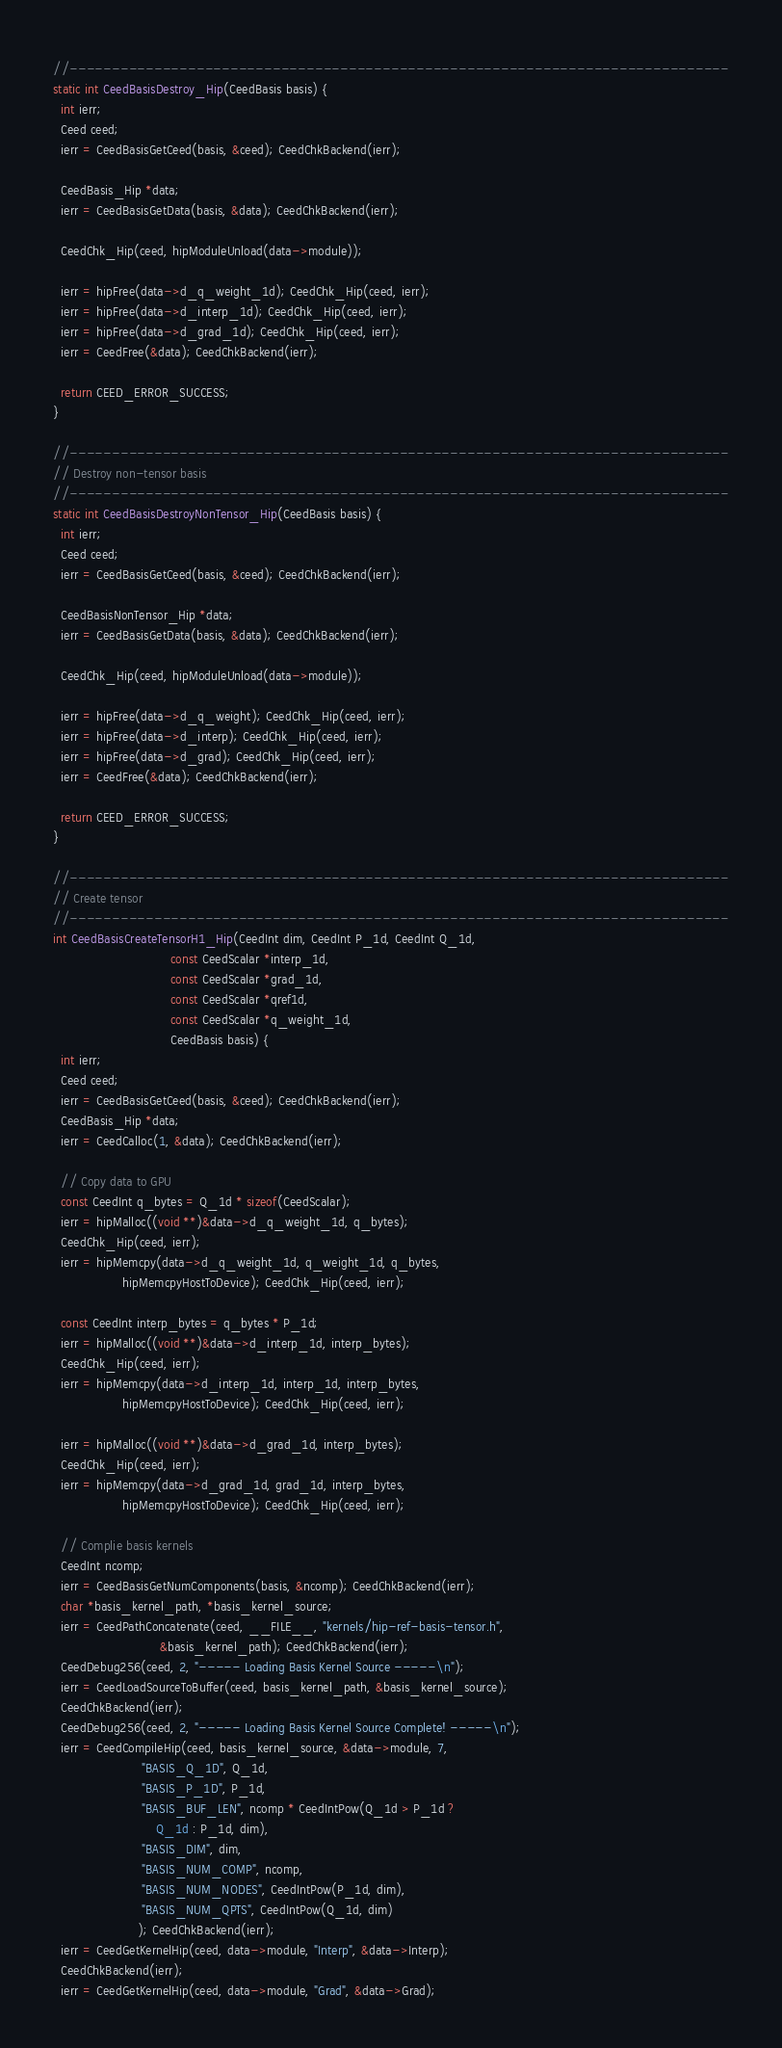<code> <loc_0><loc_0><loc_500><loc_500><_C_>//------------------------------------------------------------------------------
static int CeedBasisDestroy_Hip(CeedBasis basis) {
  int ierr;
  Ceed ceed;
  ierr = CeedBasisGetCeed(basis, &ceed); CeedChkBackend(ierr);

  CeedBasis_Hip *data;
  ierr = CeedBasisGetData(basis, &data); CeedChkBackend(ierr);

  CeedChk_Hip(ceed, hipModuleUnload(data->module));

  ierr = hipFree(data->d_q_weight_1d); CeedChk_Hip(ceed, ierr);
  ierr = hipFree(data->d_interp_1d); CeedChk_Hip(ceed, ierr);
  ierr = hipFree(data->d_grad_1d); CeedChk_Hip(ceed, ierr);
  ierr = CeedFree(&data); CeedChkBackend(ierr);

  return CEED_ERROR_SUCCESS;
}

//------------------------------------------------------------------------------
// Destroy non-tensor basis
//------------------------------------------------------------------------------
static int CeedBasisDestroyNonTensor_Hip(CeedBasis basis) {
  int ierr;
  Ceed ceed;
  ierr = CeedBasisGetCeed(basis, &ceed); CeedChkBackend(ierr);

  CeedBasisNonTensor_Hip *data;
  ierr = CeedBasisGetData(basis, &data); CeedChkBackend(ierr);

  CeedChk_Hip(ceed, hipModuleUnload(data->module));

  ierr = hipFree(data->d_q_weight); CeedChk_Hip(ceed, ierr);
  ierr = hipFree(data->d_interp); CeedChk_Hip(ceed, ierr);
  ierr = hipFree(data->d_grad); CeedChk_Hip(ceed, ierr);
  ierr = CeedFree(&data); CeedChkBackend(ierr);

  return CEED_ERROR_SUCCESS;
}

//------------------------------------------------------------------------------
// Create tensor
//------------------------------------------------------------------------------
int CeedBasisCreateTensorH1_Hip(CeedInt dim, CeedInt P_1d, CeedInt Q_1d,
                                const CeedScalar *interp_1d,
                                const CeedScalar *grad_1d,
                                const CeedScalar *qref1d,
                                const CeedScalar *q_weight_1d,
                                CeedBasis basis) {
  int ierr;
  Ceed ceed;
  ierr = CeedBasisGetCeed(basis, &ceed); CeedChkBackend(ierr);
  CeedBasis_Hip *data;
  ierr = CeedCalloc(1, &data); CeedChkBackend(ierr);

  // Copy data to GPU
  const CeedInt q_bytes = Q_1d * sizeof(CeedScalar);
  ierr = hipMalloc((void **)&data->d_q_weight_1d, q_bytes);
  CeedChk_Hip(ceed, ierr);
  ierr = hipMemcpy(data->d_q_weight_1d, q_weight_1d, q_bytes,
                   hipMemcpyHostToDevice); CeedChk_Hip(ceed, ierr);

  const CeedInt interp_bytes = q_bytes * P_1d;
  ierr = hipMalloc((void **)&data->d_interp_1d, interp_bytes);
  CeedChk_Hip(ceed, ierr);
  ierr = hipMemcpy(data->d_interp_1d, interp_1d, interp_bytes,
                   hipMemcpyHostToDevice); CeedChk_Hip(ceed, ierr);

  ierr = hipMalloc((void **)&data->d_grad_1d, interp_bytes);
  CeedChk_Hip(ceed, ierr);
  ierr = hipMemcpy(data->d_grad_1d, grad_1d, interp_bytes,
                   hipMemcpyHostToDevice); CeedChk_Hip(ceed, ierr);

  // Complie basis kernels
  CeedInt ncomp;
  ierr = CeedBasisGetNumComponents(basis, &ncomp); CeedChkBackend(ierr);
  char *basis_kernel_path, *basis_kernel_source;
  ierr = CeedPathConcatenate(ceed, __FILE__, "kernels/hip-ref-basis-tensor.h",
                             &basis_kernel_path); CeedChkBackend(ierr);
  CeedDebug256(ceed, 2, "----- Loading Basis Kernel Source -----\n");
  ierr = CeedLoadSourceToBuffer(ceed, basis_kernel_path, &basis_kernel_source);
  CeedChkBackend(ierr);
  CeedDebug256(ceed, 2, "----- Loading Basis Kernel Source Complete! -----\n");
  ierr = CeedCompileHip(ceed, basis_kernel_source, &data->module, 7,
                        "BASIS_Q_1D", Q_1d,
                        "BASIS_P_1D", P_1d,
                        "BASIS_BUF_LEN", ncomp * CeedIntPow(Q_1d > P_1d ?
                            Q_1d : P_1d, dim),
                        "BASIS_DIM", dim,
                        "BASIS_NUM_COMP", ncomp,
                        "BASIS_NUM_NODES", CeedIntPow(P_1d, dim),
                        "BASIS_NUM_QPTS", CeedIntPow(Q_1d, dim)
                       ); CeedChkBackend(ierr);
  ierr = CeedGetKernelHip(ceed, data->module, "Interp", &data->Interp);
  CeedChkBackend(ierr);
  ierr = CeedGetKernelHip(ceed, data->module, "Grad", &data->Grad);</code> 